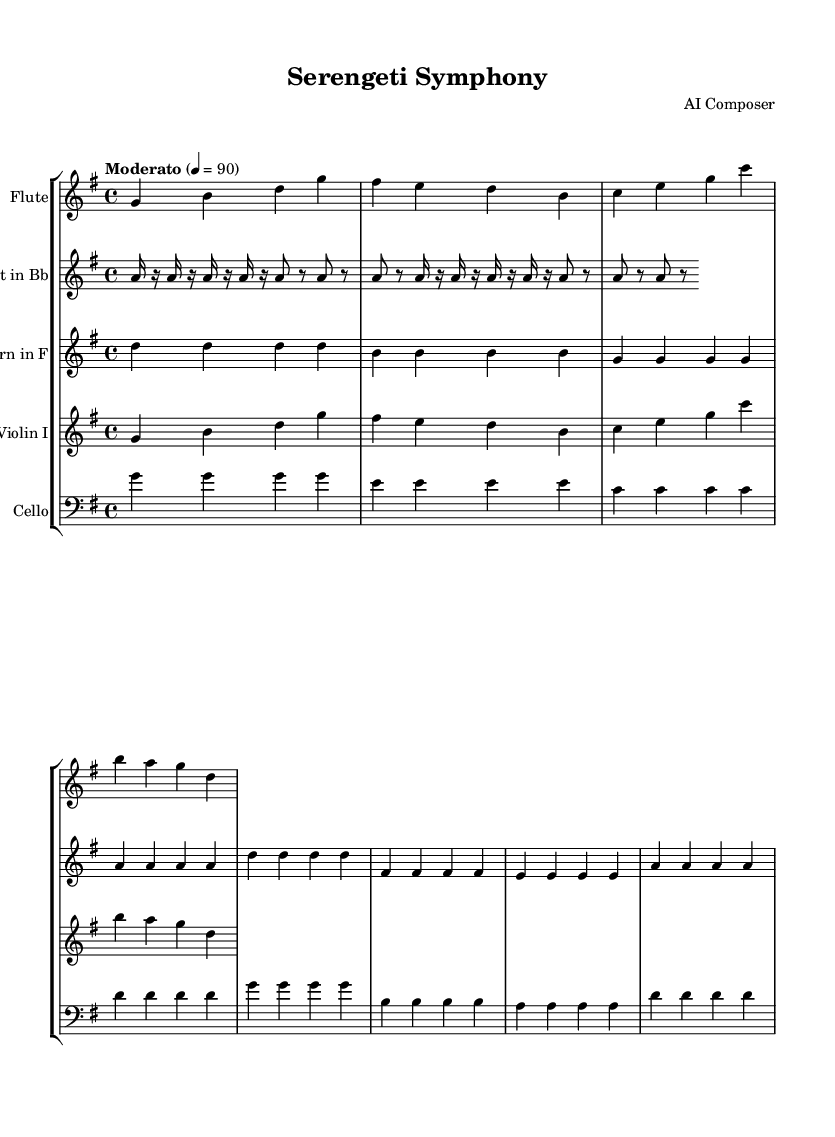What is the key signature of this music? The key signature is G major, which has one sharp (F#).
Answer: G major What is the time signature of the piece? The time signature is 4/4, indicating four beats per measure.
Answer: 4/4 What is the tempo marking for the symphony? The tempo marking is Moderato, indicating a moderate pace at 90 beats per minute.
Answer: Moderato Which instrument has the melodic line that corresponds to "Savanna Sunrise"? The melodic line "Savanna Sunrise" is primarily assigned to the Flute and Violin I.
Answer: Flute and Violin I In how many measures does the "Predator and Prey" theme repeat? The "Predator and Prey" theme is repeated twice.
Answer: Twice What type of musical form is utilized in this symphonic poem? The symphonic poem employs a thematic structure with distinct sections representing various aspects of the Serengeti ecosystem.
Answer: Thematic structure Which instrument carries the "Migration" theme in bass clef? The Cello carries the "Migration" theme in bass clef.
Answer: Cello 